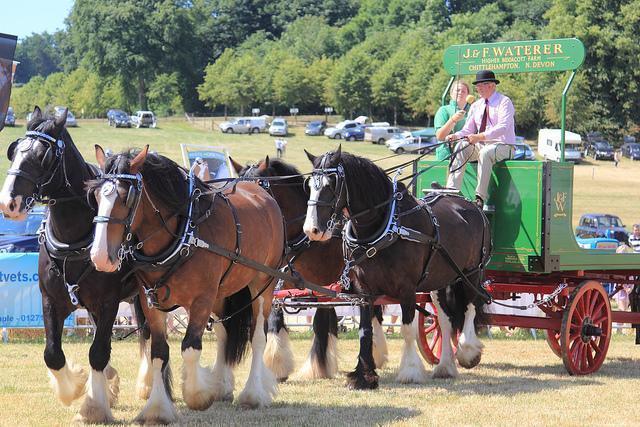What is the guy wearing a black hat doing?
From the following four choices, select the correct answer to address the question.
Options: Singing, talking, resting, listening. Talking. 